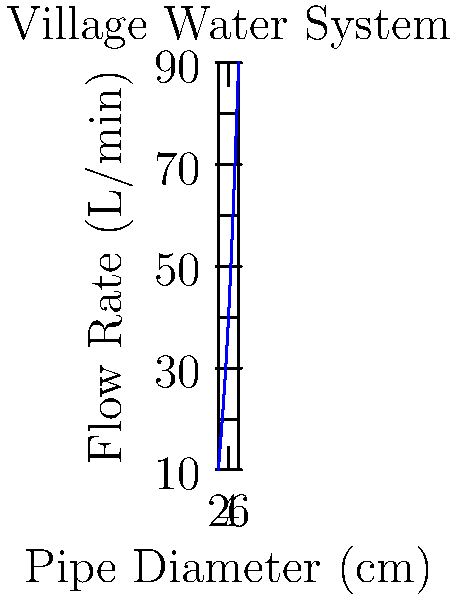As a youth leader working with the village chief to improve the community's water system, you're studying the relationship between pipe diameter and flow rate. The graph shows flow rates for different pipe diameters in the village water system. If you need to achieve a flow rate of 60 L/min, what pipe diameter (in cm) would you recommend to the village chief? Round your answer to the nearest whole number. To solve this problem, we need to analyze the graph and interpolate the required pipe diameter for a flow rate of 60 L/min. Let's break it down step-by-step:

1. Observe the graph: It shows an increasing, non-linear relationship between pipe diameter and flow rate.

2. Identify known points:
   - 2 cm diameter corresponds to about 10 L/min
   - 4 cm diameter corresponds to about 40 L/min
   - 6 cm diameter corresponds to about 90 L/min

3. Locate the target flow rate: 60 L/min falls between 40 L/min and 90 L/min.

4. Interpolate the diameter:
   - 60 L/min is halfway between 40 L/min and 90 L/min
   - So, the required diameter should be halfway between 4 cm and 6 cm

5. Calculate the diameter:
   $\text{Required diameter} = 4 \text{ cm} + \frac{6 \text{ cm} - 4 \text{ cm}}{2} = 4 \text{ cm} + 1 \text{ cm} = 5 \text{ cm}$

6. Round to the nearest whole number: 5 cm

Therefore, you would recommend a pipe diameter of 5 cm to the village chief to achieve a flow rate of 60 L/min.
Answer: 5 cm 